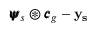<formula> <loc_0><loc_0><loc_500><loc_500>{ \pm b { \psi } } _ { s } \circledast { \pm b { c } } _ { g } - y _ { s }</formula> 